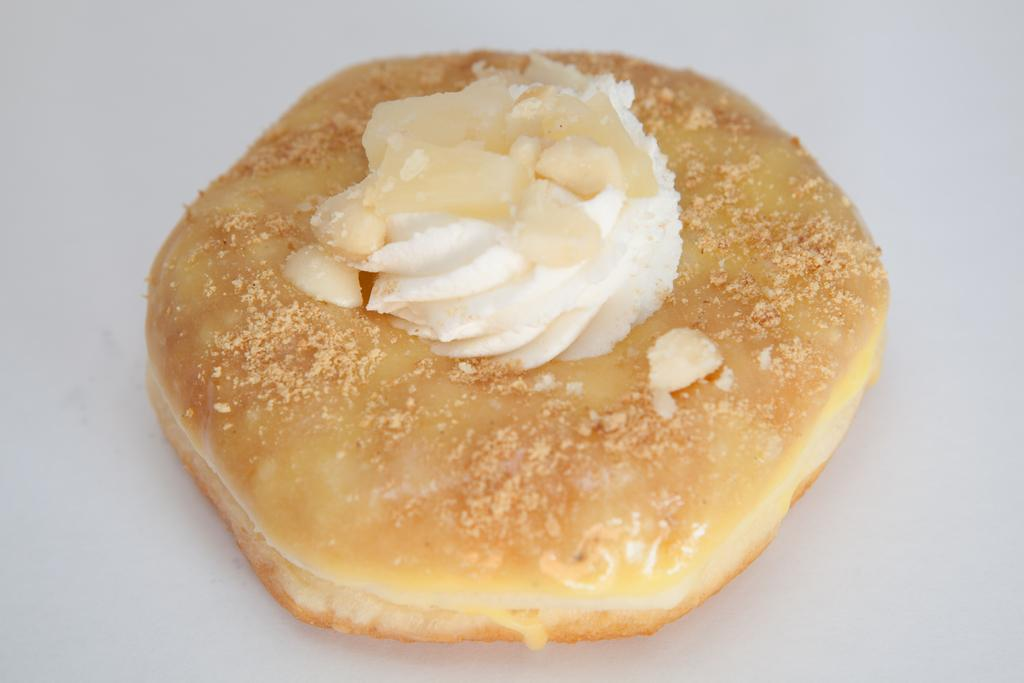What is the main subject of the image? There is a food item in the image. Can you describe the object that the food item is on? The food item is on an object. What type of polish is being applied to the wall in the image? There is no mention of polish or a wall in the image, so it is not possible to answer that question. 